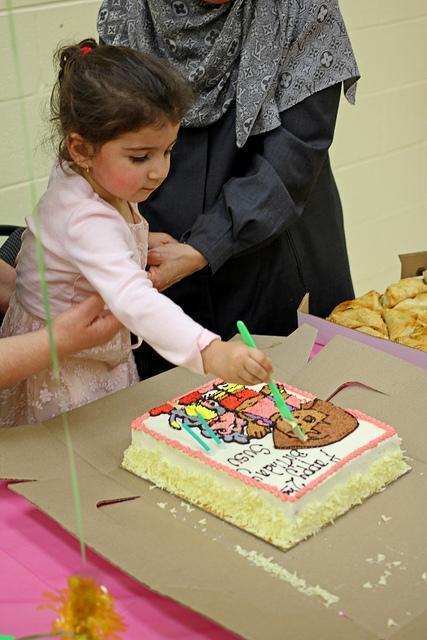How many people are in the picture?
Give a very brief answer. 2. How many people are in the photo?
Give a very brief answer. 3. 